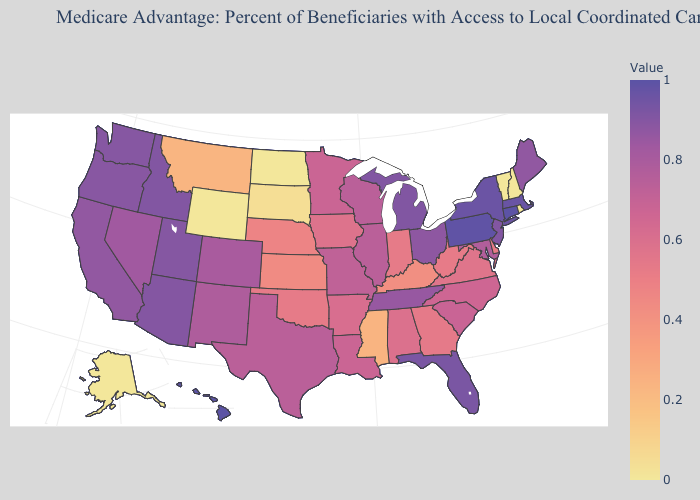Does Michigan have a higher value than South Dakota?
Concise answer only. Yes. Which states hav the highest value in the MidWest?
Short answer required. Michigan. 